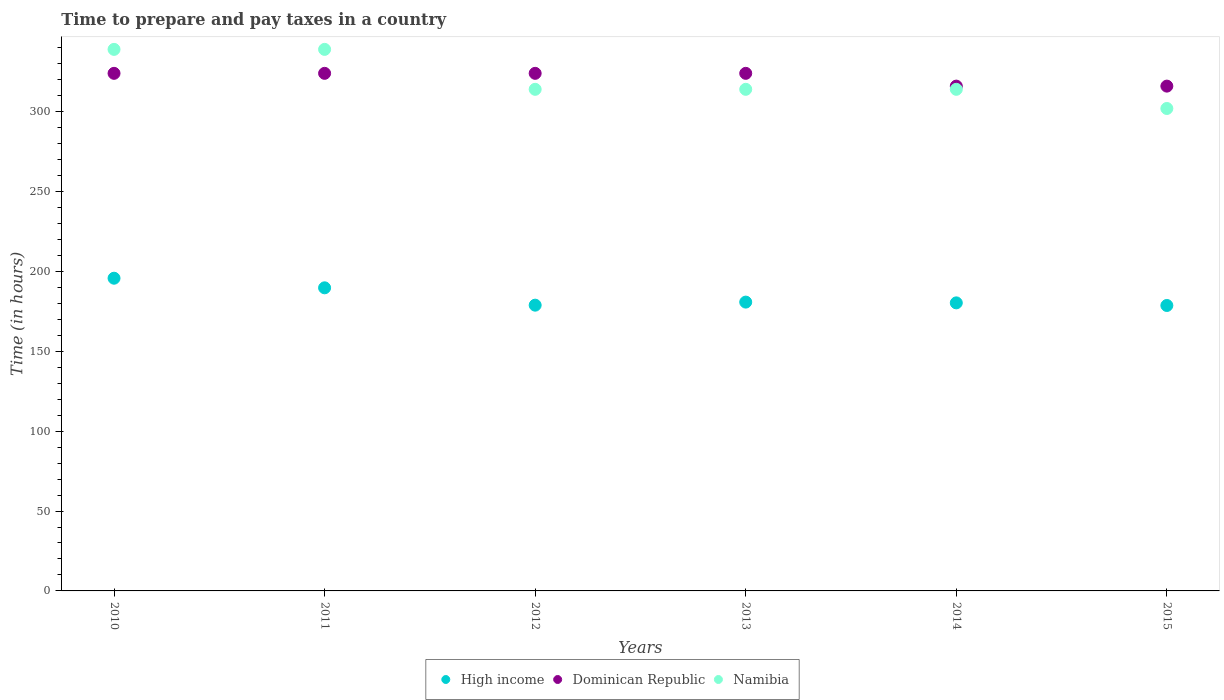Is the number of dotlines equal to the number of legend labels?
Keep it short and to the point. Yes. What is the number of hours required to prepare and pay taxes in High income in 2010?
Your answer should be very brief. 195.75. Across all years, what is the maximum number of hours required to prepare and pay taxes in Dominican Republic?
Provide a short and direct response. 324. Across all years, what is the minimum number of hours required to prepare and pay taxes in Dominican Republic?
Keep it short and to the point. 316. In which year was the number of hours required to prepare and pay taxes in Namibia maximum?
Provide a succinct answer. 2010. In which year was the number of hours required to prepare and pay taxes in High income minimum?
Ensure brevity in your answer.  2015. What is the total number of hours required to prepare and pay taxes in High income in the graph?
Provide a succinct answer. 1104.17. What is the difference between the number of hours required to prepare and pay taxes in Dominican Republic in 2011 and that in 2014?
Your answer should be compact. 8. What is the difference between the number of hours required to prepare and pay taxes in Dominican Republic in 2011 and the number of hours required to prepare and pay taxes in High income in 2010?
Provide a succinct answer. 128.25. What is the average number of hours required to prepare and pay taxes in Namibia per year?
Provide a succinct answer. 320.33. In the year 2014, what is the difference between the number of hours required to prepare and pay taxes in High income and number of hours required to prepare and pay taxes in Dominican Republic?
Keep it short and to the point. -135.68. What is the ratio of the number of hours required to prepare and pay taxes in Namibia in 2010 to that in 2015?
Your response must be concise. 1.12. Is the number of hours required to prepare and pay taxes in Namibia in 2011 less than that in 2014?
Ensure brevity in your answer.  No. What is the difference between the highest and the second highest number of hours required to prepare and pay taxes in Dominican Republic?
Your answer should be compact. 0. What is the difference between the highest and the lowest number of hours required to prepare and pay taxes in High income?
Make the answer very short. 17.07. Is the sum of the number of hours required to prepare and pay taxes in High income in 2013 and 2014 greater than the maximum number of hours required to prepare and pay taxes in Namibia across all years?
Give a very brief answer. Yes. Is it the case that in every year, the sum of the number of hours required to prepare and pay taxes in Namibia and number of hours required to prepare and pay taxes in High income  is greater than the number of hours required to prepare and pay taxes in Dominican Republic?
Make the answer very short. Yes. Does the number of hours required to prepare and pay taxes in Namibia monotonically increase over the years?
Give a very brief answer. No. Is the number of hours required to prepare and pay taxes in Namibia strictly less than the number of hours required to prepare and pay taxes in Dominican Republic over the years?
Ensure brevity in your answer.  No. What is the difference between two consecutive major ticks on the Y-axis?
Your answer should be very brief. 50. Are the values on the major ticks of Y-axis written in scientific E-notation?
Ensure brevity in your answer.  No. How many legend labels are there?
Your response must be concise. 3. What is the title of the graph?
Keep it short and to the point. Time to prepare and pay taxes in a country. What is the label or title of the X-axis?
Keep it short and to the point. Years. What is the label or title of the Y-axis?
Keep it short and to the point. Time (in hours). What is the Time (in hours) of High income in 2010?
Offer a very short reply. 195.75. What is the Time (in hours) of Dominican Republic in 2010?
Give a very brief answer. 324. What is the Time (in hours) in Namibia in 2010?
Provide a succinct answer. 339. What is the Time (in hours) in High income in 2011?
Your response must be concise. 189.74. What is the Time (in hours) of Dominican Republic in 2011?
Offer a terse response. 324. What is the Time (in hours) of Namibia in 2011?
Your response must be concise. 339. What is the Time (in hours) in High income in 2012?
Provide a short and direct response. 178.88. What is the Time (in hours) in Dominican Republic in 2012?
Your answer should be very brief. 324. What is the Time (in hours) in Namibia in 2012?
Keep it short and to the point. 314. What is the Time (in hours) of High income in 2013?
Ensure brevity in your answer.  180.8. What is the Time (in hours) of Dominican Republic in 2013?
Give a very brief answer. 324. What is the Time (in hours) in Namibia in 2013?
Your response must be concise. 314. What is the Time (in hours) of High income in 2014?
Provide a succinct answer. 180.32. What is the Time (in hours) of Dominican Republic in 2014?
Your answer should be compact. 316. What is the Time (in hours) of Namibia in 2014?
Keep it short and to the point. 314. What is the Time (in hours) in High income in 2015?
Offer a very short reply. 178.68. What is the Time (in hours) in Dominican Republic in 2015?
Ensure brevity in your answer.  316. What is the Time (in hours) of Namibia in 2015?
Your answer should be very brief. 302. Across all years, what is the maximum Time (in hours) of High income?
Offer a terse response. 195.75. Across all years, what is the maximum Time (in hours) of Dominican Republic?
Offer a terse response. 324. Across all years, what is the maximum Time (in hours) in Namibia?
Your answer should be compact. 339. Across all years, what is the minimum Time (in hours) in High income?
Your response must be concise. 178.68. Across all years, what is the minimum Time (in hours) in Dominican Republic?
Your answer should be very brief. 316. Across all years, what is the minimum Time (in hours) in Namibia?
Your answer should be very brief. 302. What is the total Time (in hours) in High income in the graph?
Offer a terse response. 1104.17. What is the total Time (in hours) in Dominican Republic in the graph?
Ensure brevity in your answer.  1928. What is the total Time (in hours) of Namibia in the graph?
Provide a succinct answer. 1922. What is the difference between the Time (in hours) in High income in 2010 and that in 2011?
Provide a short and direct response. 6.01. What is the difference between the Time (in hours) of Dominican Republic in 2010 and that in 2011?
Make the answer very short. 0. What is the difference between the Time (in hours) of High income in 2010 and that in 2012?
Offer a terse response. 16.87. What is the difference between the Time (in hours) of High income in 2010 and that in 2013?
Your answer should be very brief. 14.95. What is the difference between the Time (in hours) in Namibia in 2010 and that in 2013?
Give a very brief answer. 25. What is the difference between the Time (in hours) of High income in 2010 and that in 2014?
Your answer should be very brief. 15.43. What is the difference between the Time (in hours) of Namibia in 2010 and that in 2014?
Offer a very short reply. 25. What is the difference between the Time (in hours) in High income in 2010 and that in 2015?
Offer a very short reply. 17.07. What is the difference between the Time (in hours) in Namibia in 2010 and that in 2015?
Ensure brevity in your answer.  37. What is the difference between the Time (in hours) in High income in 2011 and that in 2012?
Ensure brevity in your answer.  10.86. What is the difference between the Time (in hours) in Namibia in 2011 and that in 2012?
Provide a short and direct response. 25. What is the difference between the Time (in hours) in High income in 2011 and that in 2013?
Your response must be concise. 8.94. What is the difference between the Time (in hours) in High income in 2011 and that in 2014?
Make the answer very short. 9.42. What is the difference between the Time (in hours) in Dominican Republic in 2011 and that in 2014?
Your answer should be compact. 8. What is the difference between the Time (in hours) of High income in 2011 and that in 2015?
Your answer should be very brief. 11.06. What is the difference between the Time (in hours) in Namibia in 2011 and that in 2015?
Make the answer very short. 37. What is the difference between the Time (in hours) of High income in 2012 and that in 2013?
Provide a short and direct response. -1.92. What is the difference between the Time (in hours) of Namibia in 2012 and that in 2013?
Give a very brief answer. 0. What is the difference between the Time (in hours) in High income in 2012 and that in 2014?
Provide a succinct answer. -1.44. What is the difference between the Time (in hours) of High income in 2012 and that in 2015?
Provide a short and direct response. 0.19. What is the difference between the Time (in hours) in Namibia in 2012 and that in 2015?
Give a very brief answer. 12. What is the difference between the Time (in hours) in High income in 2013 and that in 2014?
Make the answer very short. 0.48. What is the difference between the Time (in hours) of High income in 2013 and that in 2015?
Offer a very short reply. 2.12. What is the difference between the Time (in hours) in Namibia in 2013 and that in 2015?
Offer a terse response. 12. What is the difference between the Time (in hours) of High income in 2014 and that in 2015?
Give a very brief answer. 1.63. What is the difference between the Time (in hours) in Namibia in 2014 and that in 2015?
Give a very brief answer. 12. What is the difference between the Time (in hours) in High income in 2010 and the Time (in hours) in Dominican Republic in 2011?
Provide a succinct answer. -128.25. What is the difference between the Time (in hours) in High income in 2010 and the Time (in hours) in Namibia in 2011?
Your answer should be compact. -143.25. What is the difference between the Time (in hours) in Dominican Republic in 2010 and the Time (in hours) in Namibia in 2011?
Offer a terse response. -15. What is the difference between the Time (in hours) in High income in 2010 and the Time (in hours) in Dominican Republic in 2012?
Offer a very short reply. -128.25. What is the difference between the Time (in hours) of High income in 2010 and the Time (in hours) of Namibia in 2012?
Give a very brief answer. -118.25. What is the difference between the Time (in hours) in Dominican Republic in 2010 and the Time (in hours) in Namibia in 2012?
Ensure brevity in your answer.  10. What is the difference between the Time (in hours) in High income in 2010 and the Time (in hours) in Dominican Republic in 2013?
Ensure brevity in your answer.  -128.25. What is the difference between the Time (in hours) in High income in 2010 and the Time (in hours) in Namibia in 2013?
Provide a succinct answer. -118.25. What is the difference between the Time (in hours) of High income in 2010 and the Time (in hours) of Dominican Republic in 2014?
Offer a very short reply. -120.25. What is the difference between the Time (in hours) in High income in 2010 and the Time (in hours) in Namibia in 2014?
Offer a very short reply. -118.25. What is the difference between the Time (in hours) in Dominican Republic in 2010 and the Time (in hours) in Namibia in 2014?
Your answer should be compact. 10. What is the difference between the Time (in hours) of High income in 2010 and the Time (in hours) of Dominican Republic in 2015?
Your answer should be very brief. -120.25. What is the difference between the Time (in hours) in High income in 2010 and the Time (in hours) in Namibia in 2015?
Keep it short and to the point. -106.25. What is the difference between the Time (in hours) of Dominican Republic in 2010 and the Time (in hours) of Namibia in 2015?
Offer a very short reply. 22. What is the difference between the Time (in hours) in High income in 2011 and the Time (in hours) in Dominican Republic in 2012?
Your answer should be compact. -134.26. What is the difference between the Time (in hours) of High income in 2011 and the Time (in hours) of Namibia in 2012?
Your answer should be compact. -124.26. What is the difference between the Time (in hours) of Dominican Republic in 2011 and the Time (in hours) of Namibia in 2012?
Make the answer very short. 10. What is the difference between the Time (in hours) of High income in 2011 and the Time (in hours) of Dominican Republic in 2013?
Provide a short and direct response. -134.26. What is the difference between the Time (in hours) in High income in 2011 and the Time (in hours) in Namibia in 2013?
Give a very brief answer. -124.26. What is the difference between the Time (in hours) of Dominican Republic in 2011 and the Time (in hours) of Namibia in 2013?
Ensure brevity in your answer.  10. What is the difference between the Time (in hours) of High income in 2011 and the Time (in hours) of Dominican Republic in 2014?
Your answer should be compact. -126.26. What is the difference between the Time (in hours) in High income in 2011 and the Time (in hours) in Namibia in 2014?
Your answer should be very brief. -124.26. What is the difference between the Time (in hours) of High income in 2011 and the Time (in hours) of Dominican Republic in 2015?
Offer a terse response. -126.26. What is the difference between the Time (in hours) of High income in 2011 and the Time (in hours) of Namibia in 2015?
Provide a short and direct response. -112.26. What is the difference between the Time (in hours) in High income in 2012 and the Time (in hours) in Dominican Republic in 2013?
Offer a very short reply. -145.12. What is the difference between the Time (in hours) of High income in 2012 and the Time (in hours) of Namibia in 2013?
Your answer should be compact. -135.12. What is the difference between the Time (in hours) in High income in 2012 and the Time (in hours) in Dominican Republic in 2014?
Make the answer very short. -137.12. What is the difference between the Time (in hours) of High income in 2012 and the Time (in hours) of Namibia in 2014?
Your response must be concise. -135.12. What is the difference between the Time (in hours) in Dominican Republic in 2012 and the Time (in hours) in Namibia in 2014?
Ensure brevity in your answer.  10. What is the difference between the Time (in hours) in High income in 2012 and the Time (in hours) in Dominican Republic in 2015?
Ensure brevity in your answer.  -137.12. What is the difference between the Time (in hours) of High income in 2012 and the Time (in hours) of Namibia in 2015?
Make the answer very short. -123.12. What is the difference between the Time (in hours) of Dominican Republic in 2012 and the Time (in hours) of Namibia in 2015?
Your response must be concise. 22. What is the difference between the Time (in hours) in High income in 2013 and the Time (in hours) in Dominican Republic in 2014?
Provide a succinct answer. -135.2. What is the difference between the Time (in hours) of High income in 2013 and the Time (in hours) of Namibia in 2014?
Your answer should be very brief. -133.2. What is the difference between the Time (in hours) in Dominican Republic in 2013 and the Time (in hours) in Namibia in 2014?
Your answer should be compact. 10. What is the difference between the Time (in hours) of High income in 2013 and the Time (in hours) of Dominican Republic in 2015?
Offer a very short reply. -135.2. What is the difference between the Time (in hours) of High income in 2013 and the Time (in hours) of Namibia in 2015?
Your answer should be very brief. -121.2. What is the difference between the Time (in hours) of High income in 2014 and the Time (in hours) of Dominican Republic in 2015?
Provide a short and direct response. -135.68. What is the difference between the Time (in hours) of High income in 2014 and the Time (in hours) of Namibia in 2015?
Give a very brief answer. -121.68. What is the difference between the Time (in hours) in Dominican Republic in 2014 and the Time (in hours) in Namibia in 2015?
Give a very brief answer. 14. What is the average Time (in hours) of High income per year?
Offer a very short reply. 184.03. What is the average Time (in hours) of Dominican Republic per year?
Make the answer very short. 321.33. What is the average Time (in hours) in Namibia per year?
Offer a terse response. 320.33. In the year 2010, what is the difference between the Time (in hours) in High income and Time (in hours) in Dominican Republic?
Your response must be concise. -128.25. In the year 2010, what is the difference between the Time (in hours) in High income and Time (in hours) in Namibia?
Provide a short and direct response. -143.25. In the year 2011, what is the difference between the Time (in hours) in High income and Time (in hours) in Dominican Republic?
Keep it short and to the point. -134.26. In the year 2011, what is the difference between the Time (in hours) of High income and Time (in hours) of Namibia?
Keep it short and to the point. -149.26. In the year 2011, what is the difference between the Time (in hours) of Dominican Republic and Time (in hours) of Namibia?
Offer a very short reply. -15. In the year 2012, what is the difference between the Time (in hours) of High income and Time (in hours) of Dominican Republic?
Make the answer very short. -145.12. In the year 2012, what is the difference between the Time (in hours) in High income and Time (in hours) in Namibia?
Offer a terse response. -135.12. In the year 2012, what is the difference between the Time (in hours) in Dominican Republic and Time (in hours) in Namibia?
Make the answer very short. 10. In the year 2013, what is the difference between the Time (in hours) in High income and Time (in hours) in Dominican Republic?
Offer a terse response. -143.2. In the year 2013, what is the difference between the Time (in hours) in High income and Time (in hours) in Namibia?
Offer a terse response. -133.2. In the year 2014, what is the difference between the Time (in hours) in High income and Time (in hours) in Dominican Republic?
Your answer should be compact. -135.68. In the year 2014, what is the difference between the Time (in hours) in High income and Time (in hours) in Namibia?
Offer a very short reply. -133.68. In the year 2015, what is the difference between the Time (in hours) in High income and Time (in hours) in Dominican Republic?
Make the answer very short. -137.32. In the year 2015, what is the difference between the Time (in hours) in High income and Time (in hours) in Namibia?
Offer a terse response. -123.32. In the year 2015, what is the difference between the Time (in hours) in Dominican Republic and Time (in hours) in Namibia?
Keep it short and to the point. 14. What is the ratio of the Time (in hours) of High income in 2010 to that in 2011?
Your answer should be compact. 1.03. What is the ratio of the Time (in hours) in High income in 2010 to that in 2012?
Your response must be concise. 1.09. What is the ratio of the Time (in hours) in Dominican Republic in 2010 to that in 2012?
Your response must be concise. 1. What is the ratio of the Time (in hours) in Namibia in 2010 to that in 2012?
Your answer should be compact. 1.08. What is the ratio of the Time (in hours) in High income in 2010 to that in 2013?
Your answer should be very brief. 1.08. What is the ratio of the Time (in hours) of Dominican Republic in 2010 to that in 2013?
Offer a terse response. 1. What is the ratio of the Time (in hours) in Namibia in 2010 to that in 2013?
Provide a short and direct response. 1.08. What is the ratio of the Time (in hours) in High income in 2010 to that in 2014?
Provide a succinct answer. 1.09. What is the ratio of the Time (in hours) of Dominican Republic in 2010 to that in 2014?
Provide a short and direct response. 1.03. What is the ratio of the Time (in hours) of Namibia in 2010 to that in 2014?
Provide a short and direct response. 1.08. What is the ratio of the Time (in hours) in High income in 2010 to that in 2015?
Provide a succinct answer. 1.1. What is the ratio of the Time (in hours) of Dominican Republic in 2010 to that in 2015?
Make the answer very short. 1.03. What is the ratio of the Time (in hours) in Namibia in 2010 to that in 2015?
Offer a terse response. 1.12. What is the ratio of the Time (in hours) of High income in 2011 to that in 2012?
Offer a very short reply. 1.06. What is the ratio of the Time (in hours) in Namibia in 2011 to that in 2012?
Make the answer very short. 1.08. What is the ratio of the Time (in hours) of High income in 2011 to that in 2013?
Keep it short and to the point. 1.05. What is the ratio of the Time (in hours) of Dominican Republic in 2011 to that in 2013?
Your answer should be compact. 1. What is the ratio of the Time (in hours) of Namibia in 2011 to that in 2013?
Your answer should be very brief. 1.08. What is the ratio of the Time (in hours) in High income in 2011 to that in 2014?
Provide a succinct answer. 1.05. What is the ratio of the Time (in hours) in Dominican Republic in 2011 to that in 2014?
Give a very brief answer. 1.03. What is the ratio of the Time (in hours) of Namibia in 2011 to that in 2014?
Your answer should be very brief. 1.08. What is the ratio of the Time (in hours) of High income in 2011 to that in 2015?
Offer a very short reply. 1.06. What is the ratio of the Time (in hours) of Dominican Republic in 2011 to that in 2015?
Your answer should be very brief. 1.03. What is the ratio of the Time (in hours) in Namibia in 2011 to that in 2015?
Ensure brevity in your answer.  1.12. What is the ratio of the Time (in hours) of Dominican Republic in 2012 to that in 2014?
Offer a terse response. 1.03. What is the ratio of the Time (in hours) of Namibia in 2012 to that in 2014?
Ensure brevity in your answer.  1. What is the ratio of the Time (in hours) in High income in 2012 to that in 2015?
Ensure brevity in your answer.  1. What is the ratio of the Time (in hours) in Dominican Republic in 2012 to that in 2015?
Your answer should be very brief. 1.03. What is the ratio of the Time (in hours) of Namibia in 2012 to that in 2015?
Offer a terse response. 1.04. What is the ratio of the Time (in hours) in High income in 2013 to that in 2014?
Offer a terse response. 1. What is the ratio of the Time (in hours) in Dominican Republic in 2013 to that in 2014?
Your response must be concise. 1.03. What is the ratio of the Time (in hours) in High income in 2013 to that in 2015?
Provide a succinct answer. 1.01. What is the ratio of the Time (in hours) in Dominican Republic in 2013 to that in 2015?
Provide a short and direct response. 1.03. What is the ratio of the Time (in hours) of Namibia in 2013 to that in 2015?
Make the answer very short. 1.04. What is the ratio of the Time (in hours) of High income in 2014 to that in 2015?
Your answer should be compact. 1.01. What is the ratio of the Time (in hours) in Namibia in 2014 to that in 2015?
Offer a terse response. 1.04. What is the difference between the highest and the second highest Time (in hours) of High income?
Ensure brevity in your answer.  6.01. What is the difference between the highest and the second highest Time (in hours) in Dominican Republic?
Provide a succinct answer. 0. What is the difference between the highest and the lowest Time (in hours) in High income?
Your answer should be compact. 17.07. What is the difference between the highest and the lowest Time (in hours) of Dominican Republic?
Offer a very short reply. 8. What is the difference between the highest and the lowest Time (in hours) of Namibia?
Your answer should be compact. 37. 